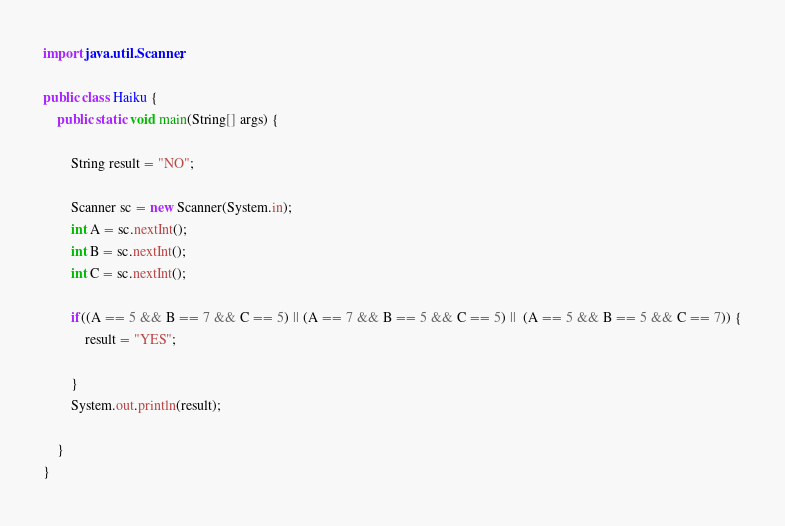<code> <loc_0><loc_0><loc_500><loc_500><_Java_>import java.util.Scanner;

public class Haiku {
	public static void main(String[] args) {
		
		String result = "NO";
		
		Scanner sc = new Scanner(System.in);
		int A = sc.nextInt();
		int B = sc.nextInt();
		int C = sc.nextInt();
		
		if((A == 5 && B == 7 && C == 5) || (A == 7 && B == 5 && C == 5) ||  (A == 5 && B == 5 && C == 7)) {
			result = "YES";
			
		}
		System.out.println(result);

	}
}
</code> 